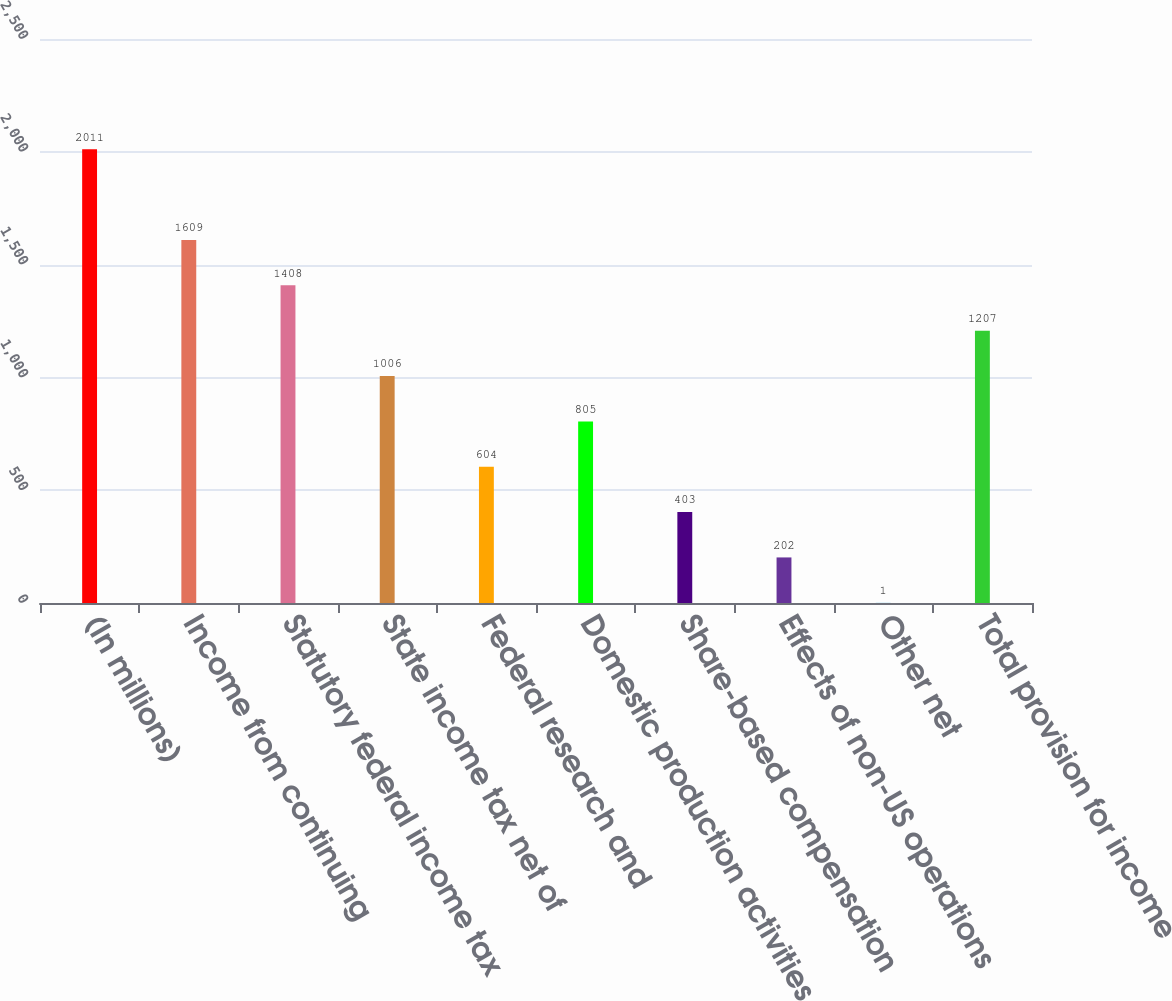<chart> <loc_0><loc_0><loc_500><loc_500><bar_chart><fcel>(In millions)<fcel>Income from continuing<fcel>Statutory federal income tax<fcel>State income tax net of<fcel>Federal research and<fcel>Domestic production activities<fcel>Share-based compensation<fcel>Effects of non-US operations<fcel>Other net<fcel>Total provision for income<nl><fcel>2011<fcel>1609<fcel>1408<fcel>1006<fcel>604<fcel>805<fcel>403<fcel>202<fcel>1<fcel>1207<nl></chart> 